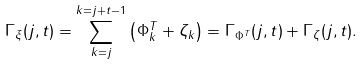<formula> <loc_0><loc_0><loc_500><loc_500>\Gamma _ { \xi } ( j , t ) = \sum _ { k = j } ^ { k = j + t - 1 } \left ( \Phi _ { k } ^ { T } + \zeta _ { k } \right ) = \Gamma _ { \Phi ^ { T } } ( j , t ) + \Gamma _ { \zeta } ( j , t ) .</formula> 